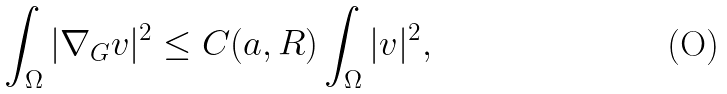Convert formula to latex. <formula><loc_0><loc_0><loc_500><loc_500>\int _ { \Omega } | \nabla _ { G } v | ^ { 2 } \leq C ( a , R ) \int _ { \Omega } | v | ^ { 2 } ,</formula> 